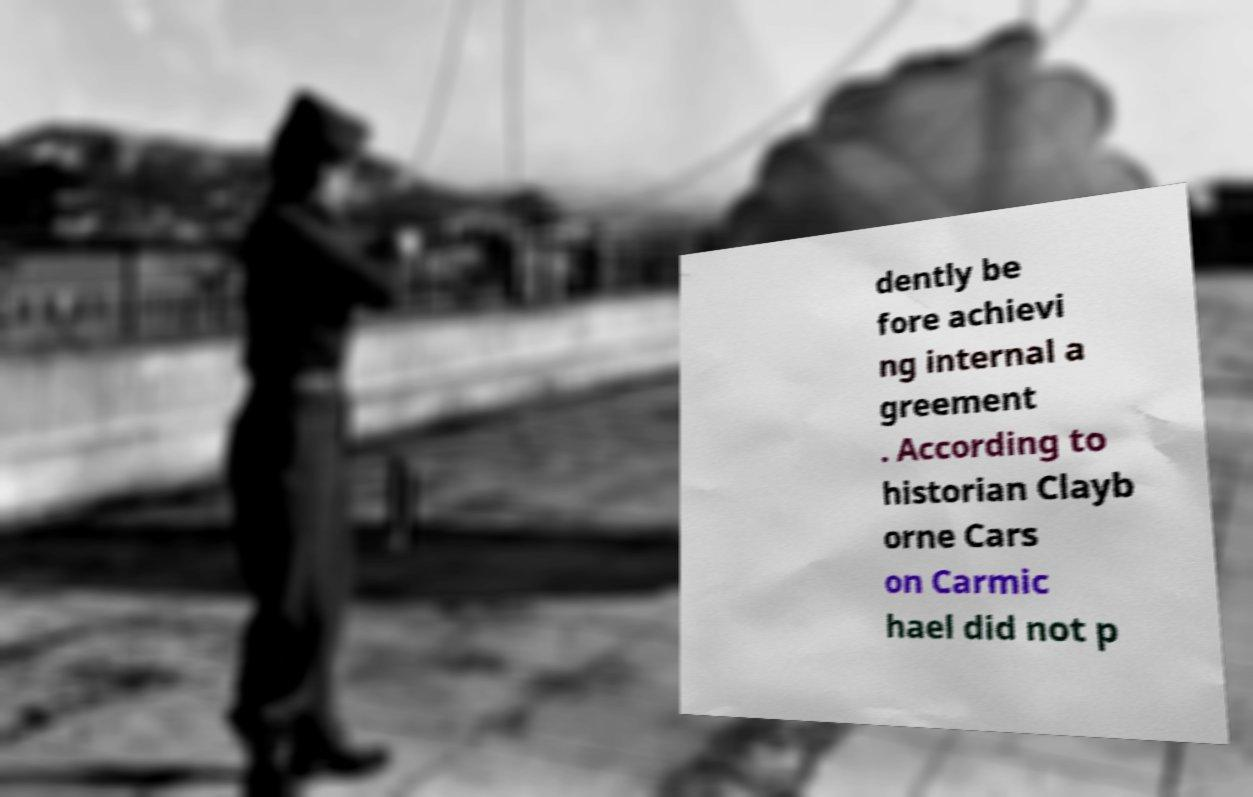Please identify and transcribe the text found in this image. dently be fore achievi ng internal a greement . According to historian Clayb orne Cars on Carmic hael did not p 